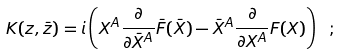Convert formula to latex. <formula><loc_0><loc_0><loc_500><loc_500>K ( z , \bar { z } ) = i \left ( X ^ { A } \frac { \partial } { \partial \bar { X } ^ { A } } \bar { F } ( \bar { X } ) - \bar { X } ^ { A } \frac { \partial } { \partial X ^ { A } } F ( X ) \right ) \ ;</formula> 